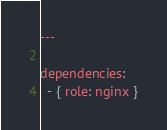Convert code to text. <code><loc_0><loc_0><loc_500><loc_500><_YAML_>---

dependencies:
  - { role: nginx }</code> 